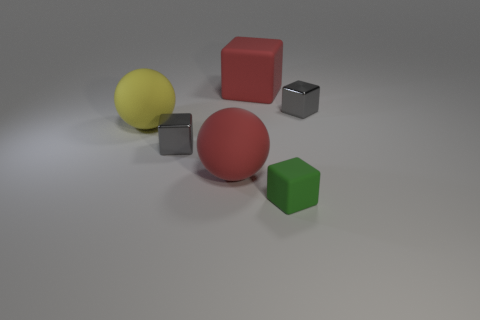Subtract all green cubes. How many cubes are left? 3 Subtract all purple spheres. How many gray cubes are left? 2 Subtract all green blocks. How many blocks are left? 3 Add 2 large yellow objects. How many objects exist? 8 Subtract all cubes. How many objects are left? 2 Subtract 0 gray cylinders. How many objects are left? 6 Subtract all gray spheres. Subtract all yellow cylinders. How many spheres are left? 2 Subtract all green rubber objects. Subtract all big yellow matte things. How many objects are left? 4 Add 4 big balls. How many big balls are left? 6 Add 6 big red cubes. How many big red cubes exist? 7 